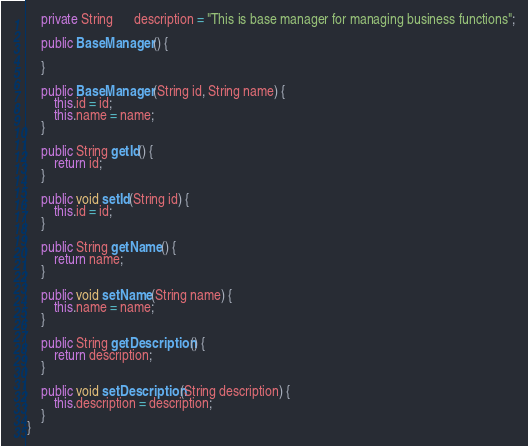Convert code to text. <code><loc_0><loc_0><loc_500><loc_500><_Java_>    private String      description = "This is base manager for managing business functions";

    public BaseManager() {

    }

    public BaseManager(String id, String name) {
        this.id = id;
        this.name = name;
    }

    public String getId() {
        return id;
    }

    public void setId(String id) {
        this.id = id;
    }

    public String getName() {
        return name;
    }

    public void setName(String name) {
        this.name = name;
    }

    public String getDescription() {
        return description;
    }

    public void setDescription(String description) {
        this.description = description;
    }
}

</code> 